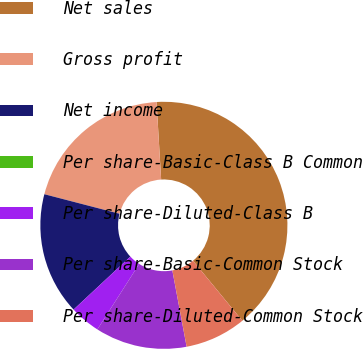Convert chart. <chart><loc_0><loc_0><loc_500><loc_500><pie_chart><fcel>Net sales<fcel>Gross profit<fcel>Net income<fcel>Per share-Basic-Class B Common<fcel>Per share-Diluted-Class B<fcel>Per share-Basic-Common Stock<fcel>Per share-Diluted-Common Stock<nl><fcel>40.0%<fcel>20.0%<fcel>16.0%<fcel>0.0%<fcel>4.0%<fcel>12.0%<fcel>8.0%<nl></chart> 